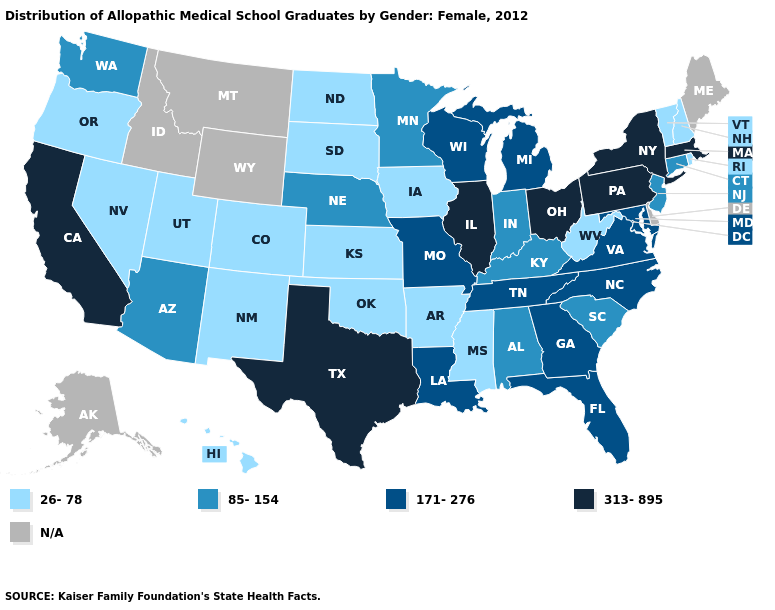What is the value of Michigan?
Be succinct. 171-276. Among the states that border Michigan , does Ohio have the highest value?
Answer briefly. Yes. What is the highest value in states that border New Hampshire?
Answer briefly. 313-895. Name the states that have a value in the range N/A?
Keep it brief. Alaska, Delaware, Idaho, Maine, Montana, Wyoming. What is the lowest value in states that border Nebraska?
Give a very brief answer. 26-78. Does Connecticut have the lowest value in the USA?
Answer briefly. No. What is the lowest value in the USA?
Answer briefly. 26-78. What is the value of California?
Keep it brief. 313-895. Name the states that have a value in the range 26-78?
Keep it brief. Arkansas, Colorado, Hawaii, Iowa, Kansas, Mississippi, Nevada, New Hampshire, New Mexico, North Dakota, Oklahoma, Oregon, Rhode Island, South Dakota, Utah, Vermont, West Virginia. Name the states that have a value in the range N/A?
Concise answer only. Alaska, Delaware, Idaho, Maine, Montana, Wyoming. Name the states that have a value in the range 171-276?
Give a very brief answer. Florida, Georgia, Louisiana, Maryland, Michigan, Missouri, North Carolina, Tennessee, Virginia, Wisconsin. What is the value of North Dakota?
Concise answer only. 26-78. What is the value of Montana?
Give a very brief answer. N/A. Does Kansas have the lowest value in the MidWest?
Write a very short answer. Yes. 